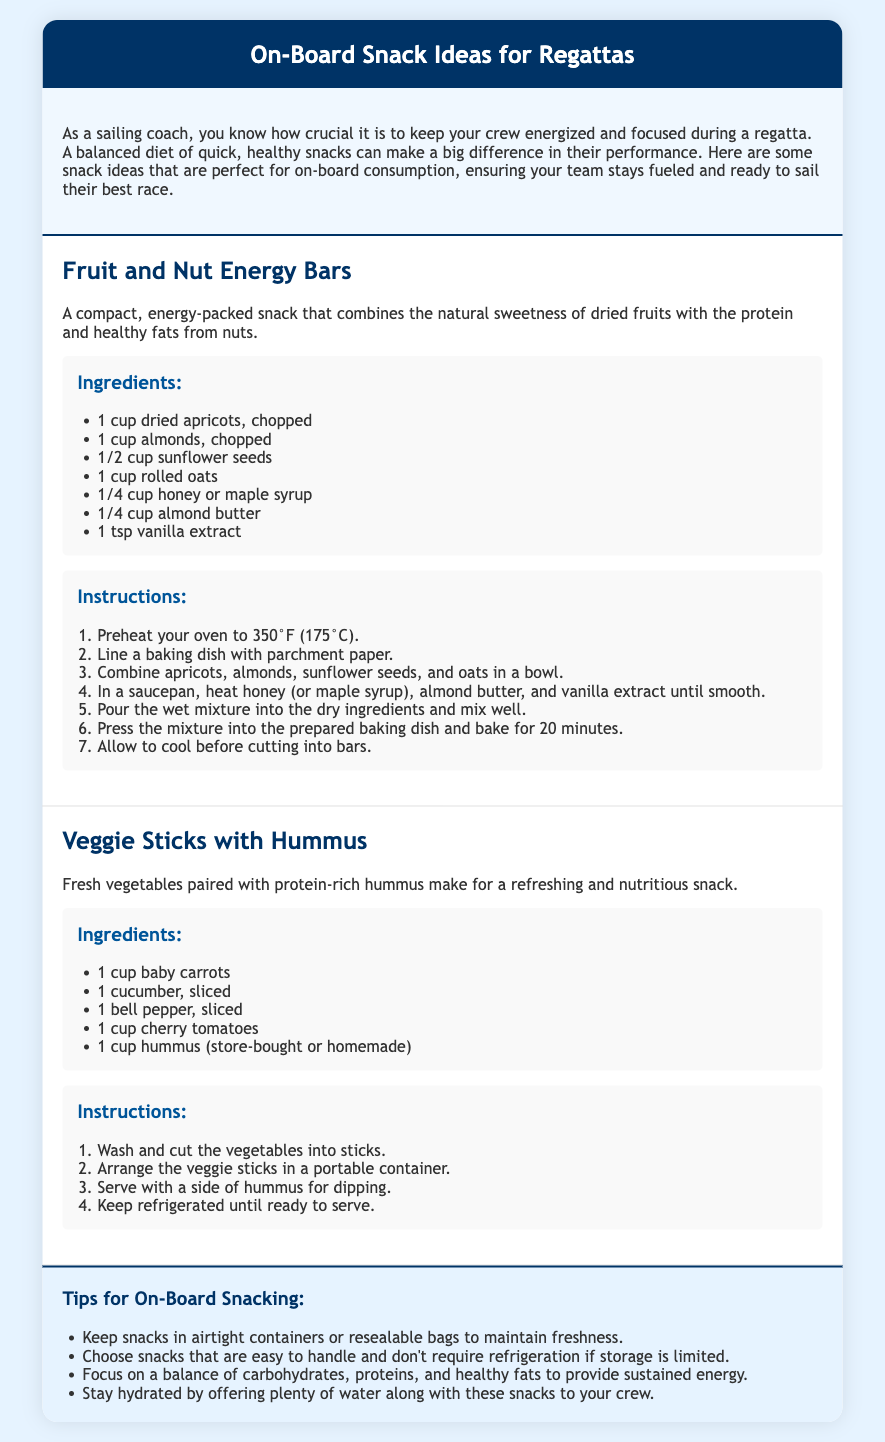What is the first snack recipe listed? The first snack recipe mentioned in the document is "Fruit and Nut Energy Bars."
Answer: Fruit and Nut Energy Bars How many ingredients are listed for the Veggie Sticks with Hummus? The Veggie Sticks with Hummus recipe lists five ingredients.
Answer: 5 What is the temperature to preheat the oven for the first recipe? The oven should be preheated to 350°F (175°C) for the Fruit and Nut Energy Bars.
Answer: 350°F (175°C) What type of snack is suggested for a refreshing and nutritious option? The document suggests "Veggie Sticks with Hummus" as a refreshing and nutritious snack.
Answer: Veggie Sticks with Hummus What key tips are provided for on-board snacking? One of the tips emphasizes keeping snacks in airtight containers to maintain freshness.
Answer: Airtight containers How long should the Fruit and Nut Energy Bars bake? The baking time for the Fruit and Nut Energy Bars is 20 minutes.
Answer: 20 minutes What is a serving suggestion for the Veggie Sticks? The Veggie Sticks should be served with a side of hummus for dipping.
Answer: Hummus What is suggested to keep alongside the snacks? The document suggests offering plenty of water along with the snacks.
Answer: Water 